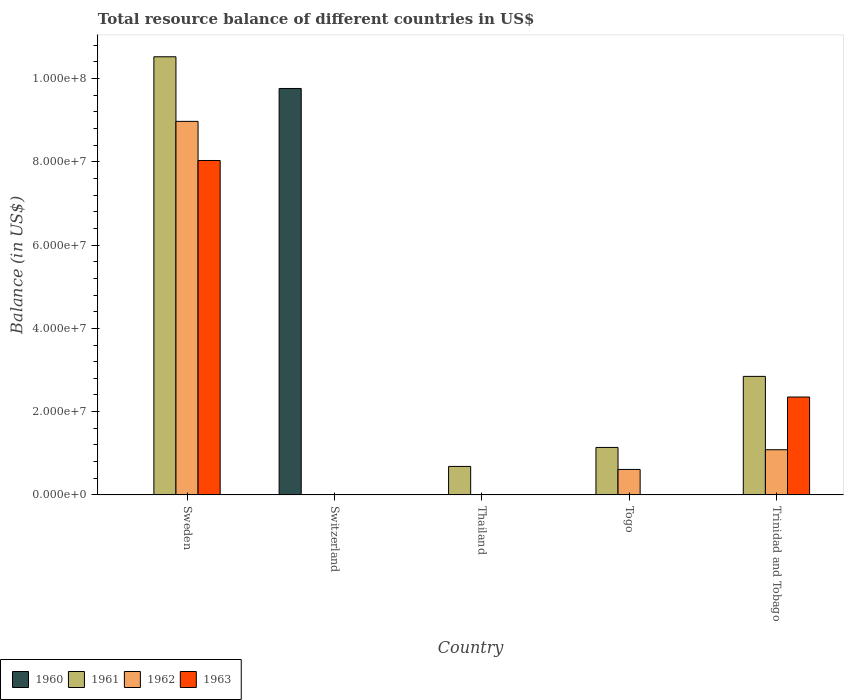How many different coloured bars are there?
Keep it short and to the point. 4. Are the number of bars per tick equal to the number of legend labels?
Ensure brevity in your answer.  No. Are the number of bars on each tick of the X-axis equal?
Ensure brevity in your answer.  No. How many bars are there on the 4th tick from the right?
Offer a terse response. 1. What is the label of the 3rd group of bars from the left?
Your answer should be very brief. Thailand. In how many cases, is the number of bars for a given country not equal to the number of legend labels?
Offer a terse response. 5. What is the total resource balance in 1962 in Togo?
Offer a terse response. 6.11e+06. Across all countries, what is the maximum total resource balance in 1963?
Your answer should be compact. 8.03e+07. Across all countries, what is the minimum total resource balance in 1961?
Offer a terse response. 0. In which country was the total resource balance in 1960 maximum?
Your answer should be very brief. Switzerland. What is the total total resource balance in 1960 in the graph?
Provide a succinct answer. 9.76e+07. What is the difference between the total resource balance in 1961 in Thailand and that in Togo?
Give a very brief answer. -4.56e+06. What is the difference between the total resource balance in 1963 in Thailand and the total resource balance in 1962 in Trinidad and Tobago?
Provide a succinct answer. -1.08e+07. What is the average total resource balance in 1963 per country?
Offer a terse response. 2.08e+07. What is the difference between the total resource balance of/in 1962 and total resource balance of/in 1963 in Trinidad and Tobago?
Your response must be concise. -1.27e+07. In how many countries, is the total resource balance in 1961 greater than 52000000 US$?
Keep it short and to the point. 1. What is the ratio of the total resource balance in 1962 in Sweden to that in Togo?
Offer a terse response. 14.68. What is the difference between the highest and the second highest total resource balance in 1961?
Make the answer very short. -9.38e+07. What is the difference between the highest and the lowest total resource balance in 1960?
Provide a short and direct response. 9.76e+07. In how many countries, is the total resource balance in 1961 greater than the average total resource balance in 1961 taken over all countries?
Provide a short and direct response. 1. Is the sum of the total resource balance in 1962 in Togo and Trinidad and Tobago greater than the maximum total resource balance in 1960 across all countries?
Ensure brevity in your answer.  No. How many bars are there?
Give a very brief answer. 10. How many countries are there in the graph?
Keep it short and to the point. 5. Does the graph contain any zero values?
Your answer should be compact. Yes. Where does the legend appear in the graph?
Your answer should be compact. Bottom left. How many legend labels are there?
Keep it short and to the point. 4. What is the title of the graph?
Your response must be concise. Total resource balance of different countries in US$. What is the label or title of the X-axis?
Your answer should be compact. Country. What is the label or title of the Y-axis?
Provide a short and direct response. Balance (in US$). What is the Balance (in US$) of 1961 in Sweden?
Provide a succinct answer. 1.05e+08. What is the Balance (in US$) in 1962 in Sweden?
Give a very brief answer. 8.97e+07. What is the Balance (in US$) of 1963 in Sweden?
Keep it short and to the point. 8.03e+07. What is the Balance (in US$) in 1960 in Switzerland?
Make the answer very short. 9.76e+07. What is the Balance (in US$) in 1961 in Switzerland?
Your answer should be compact. 0. What is the Balance (in US$) of 1962 in Switzerland?
Your response must be concise. 0. What is the Balance (in US$) in 1961 in Thailand?
Provide a succinct answer. 6.84e+06. What is the Balance (in US$) in 1963 in Thailand?
Make the answer very short. 0. What is the Balance (in US$) of 1960 in Togo?
Give a very brief answer. 0. What is the Balance (in US$) of 1961 in Togo?
Your response must be concise. 1.14e+07. What is the Balance (in US$) of 1962 in Togo?
Make the answer very short. 6.11e+06. What is the Balance (in US$) of 1963 in Togo?
Give a very brief answer. 0. What is the Balance (in US$) in 1960 in Trinidad and Tobago?
Keep it short and to the point. 0. What is the Balance (in US$) in 1961 in Trinidad and Tobago?
Provide a short and direct response. 2.85e+07. What is the Balance (in US$) of 1962 in Trinidad and Tobago?
Your answer should be compact. 1.08e+07. What is the Balance (in US$) in 1963 in Trinidad and Tobago?
Make the answer very short. 2.35e+07. Across all countries, what is the maximum Balance (in US$) in 1960?
Make the answer very short. 9.76e+07. Across all countries, what is the maximum Balance (in US$) of 1961?
Offer a very short reply. 1.05e+08. Across all countries, what is the maximum Balance (in US$) in 1962?
Your answer should be compact. 8.97e+07. Across all countries, what is the maximum Balance (in US$) of 1963?
Give a very brief answer. 8.03e+07. Across all countries, what is the minimum Balance (in US$) of 1960?
Keep it short and to the point. 0. Across all countries, what is the minimum Balance (in US$) of 1961?
Offer a terse response. 0. Across all countries, what is the minimum Balance (in US$) of 1963?
Ensure brevity in your answer.  0. What is the total Balance (in US$) in 1960 in the graph?
Your response must be concise. 9.76e+07. What is the total Balance (in US$) in 1961 in the graph?
Keep it short and to the point. 1.52e+08. What is the total Balance (in US$) of 1962 in the graph?
Provide a succinct answer. 1.07e+08. What is the total Balance (in US$) of 1963 in the graph?
Offer a terse response. 1.04e+08. What is the difference between the Balance (in US$) in 1961 in Sweden and that in Thailand?
Your response must be concise. 9.84e+07. What is the difference between the Balance (in US$) in 1961 in Sweden and that in Togo?
Ensure brevity in your answer.  9.38e+07. What is the difference between the Balance (in US$) of 1962 in Sweden and that in Togo?
Give a very brief answer. 8.36e+07. What is the difference between the Balance (in US$) in 1961 in Sweden and that in Trinidad and Tobago?
Your answer should be compact. 7.68e+07. What is the difference between the Balance (in US$) in 1962 in Sweden and that in Trinidad and Tobago?
Provide a short and direct response. 7.89e+07. What is the difference between the Balance (in US$) of 1963 in Sweden and that in Trinidad and Tobago?
Ensure brevity in your answer.  5.68e+07. What is the difference between the Balance (in US$) of 1961 in Thailand and that in Togo?
Offer a terse response. -4.56e+06. What is the difference between the Balance (in US$) in 1961 in Thailand and that in Trinidad and Tobago?
Offer a very short reply. -2.16e+07. What is the difference between the Balance (in US$) of 1961 in Togo and that in Trinidad and Tobago?
Offer a very short reply. -1.71e+07. What is the difference between the Balance (in US$) in 1962 in Togo and that in Trinidad and Tobago?
Provide a short and direct response. -4.74e+06. What is the difference between the Balance (in US$) of 1961 in Sweden and the Balance (in US$) of 1962 in Togo?
Your answer should be compact. 9.91e+07. What is the difference between the Balance (in US$) in 1961 in Sweden and the Balance (in US$) in 1962 in Trinidad and Tobago?
Make the answer very short. 9.44e+07. What is the difference between the Balance (in US$) of 1961 in Sweden and the Balance (in US$) of 1963 in Trinidad and Tobago?
Your answer should be compact. 8.17e+07. What is the difference between the Balance (in US$) in 1962 in Sweden and the Balance (in US$) in 1963 in Trinidad and Tobago?
Provide a short and direct response. 6.62e+07. What is the difference between the Balance (in US$) of 1960 in Switzerland and the Balance (in US$) of 1961 in Thailand?
Keep it short and to the point. 9.08e+07. What is the difference between the Balance (in US$) in 1960 in Switzerland and the Balance (in US$) in 1961 in Togo?
Give a very brief answer. 8.62e+07. What is the difference between the Balance (in US$) of 1960 in Switzerland and the Balance (in US$) of 1962 in Togo?
Your response must be concise. 9.15e+07. What is the difference between the Balance (in US$) of 1960 in Switzerland and the Balance (in US$) of 1961 in Trinidad and Tobago?
Make the answer very short. 6.92e+07. What is the difference between the Balance (in US$) in 1960 in Switzerland and the Balance (in US$) in 1962 in Trinidad and Tobago?
Keep it short and to the point. 8.68e+07. What is the difference between the Balance (in US$) of 1960 in Switzerland and the Balance (in US$) of 1963 in Trinidad and Tobago?
Offer a very short reply. 7.41e+07. What is the difference between the Balance (in US$) of 1961 in Thailand and the Balance (in US$) of 1962 in Togo?
Make the answer very short. 7.25e+05. What is the difference between the Balance (in US$) in 1961 in Thailand and the Balance (in US$) in 1962 in Trinidad and Tobago?
Provide a short and direct response. -4.01e+06. What is the difference between the Balance (in US$) of 1961 in Thailand and the Balance (in US$) of 1963 in Trinidad and Tobago?
Offer a terse response. -1.67e+07. What is the difference between the Balance (in US$) in 1961 in Togo and the Balance (in US$) in 1962 in Trinidad and Tobago?
Your answer should be compact. 5.50e+05. What is the difference between the Balance (in US$) of 1961 in Togo and the Balance (in US$) of 1963 in Trinidad and Tobago?
Offer a terse response. -1.21e+07. What is the difference between the Balance (in US$) of 1962 in Togo and the Balance (in US$) of 1963 in Trinidad and Tobago?
Ensure brevity in your answer.  -1.74e+07. What is the average Balance (in US$) of 1960 per country?
Make the answer very short. 1.95e+07. What is the average Balance (in US$) of 1961 per country?
Your response must be concise. 3.04e+07. What is the average Balance (in US$) in 1962 per country?
Ensure brevity in your answer.  2.13e+07. What is the average Balance (in US$) of 1963 per country?
Ensure brevity in your answer.  2.08e+07. What is the difference between the Balance (in US$) in 1961 and Balance (in US$) in 1962 in Sweden?
Make the answer very short. 1.55e+07. What is the difference between the Balance (in US$) of 1961 and Balance (in US$) of 1963 in Sweden?
Offer a very short reply. 2.49e+07. What is the difference between the Balance (in US$) of 1962 and Balance (in US$) of 1963 in Sweden?
Provide a succinct answer. 9.40e+06. What is the difference between the Balance (in US$) of 1961 and Balance (in US$) of 1962 in Togo?
Provide a succinct answer. 5.29e+06. What is the difference between the Balance (in US$) in 1961 and Balance (in US$) in 1962 in Trinidad and Tobago?
Make the answer very short. 1.76e+07. What is the difference between the Balance (in US$) of 1961 and Balance (in US$) of 1963 in Trinidad and Tobago?
Your answer should be compact. 4.96e+06. What is the difference between the Balance (in US$) in 1962 and Balance (in US$) in 1963 in Trinidad and Tobago?
Your answer should be very brief. -1.27e+07. What is the ratio of the Balance (in US$) in 1961 in Sweden to that in Thailand?
Provide a short and direct response. 15.39. What is the ratio of the Balance (in US$) of 1961 in Sweden to that in Togo?
Your response must be concise. 9.23. What is the ratio of the Balance (in US$) in 1962 in Sweden to that in Togo?
Your answer should be very brief. 14.68. What is the ratio of the Balance (in US$) in 1961 in Sweden to that in Trinidad and Tobago?
Provide a short and direct response. 3.7. What is the ratio of the Balance (in US$) of 1962 in Sweden to that in Trinidad and Tobago?
Ensure brevity in your answer.  8.27. What is the ratio of the Balance (in US$) in 1963 in Sweden to that in Trinidad and Tobago?
Provide a short and direct response. 3.42. What is the ratio of the Balance (in US$) in 1961 in Thailand to that in Togo?
Keep it short and to the point. 0.6. What is the ratio of the Balance (in US$) in 1961 in Thailand to that in Trinidad and Tobago?
Offer a terse response. 0.24. What is the ratio of the Balance (in US$) of 1961 in Togo to that in Trinidad and Tobago?
Ensure brevity in your answer.  0.4. What is the ratio of the Balance (in US$) in 1962 in Togo to that in Trinidad and Tobago?
Offer a terse response. 0.56. What is the difference between the highest and the second highest Balance (in US$) of 1961?
Make the answer very short. 7.68e+07. What is the difference between the highest and the second highest Balance (in US$) in 1962?
Keep it short and to the point. 7.89e+07. What is the difference between the highest and the lowest Balance (in US$) of 1960?
Ensure brevity in your answer.  9.76e+07. What is the difference between the highest and the lowest Balance (in US$) in 1961?
Keep it short and to the point. 1.05e+08. What is the difference between the highest and the lowest Balance (in US$) of 1962?
Make the answer very short. 8.97e+07. What is the difference between the highest and the lowest Balance (in US$) of 1963?
Make the answer very short. 8.03e+07. 